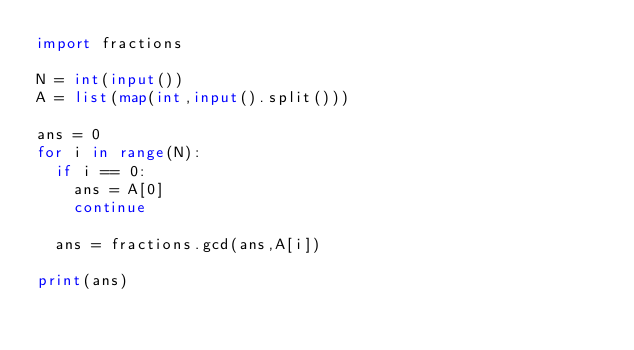Convert code to text. <code><loc_0><loc_0><loc_500><loc_500><_Python_>import fractions 

N = int(input())
A = list(map(int,input().split()))
 
ans = 0
for i in range(N):
  if i == 0:
    ans = A[0]
    continue
 
  ans = fractions.gcd(ans,A[i])
  
print(ans)</code> 